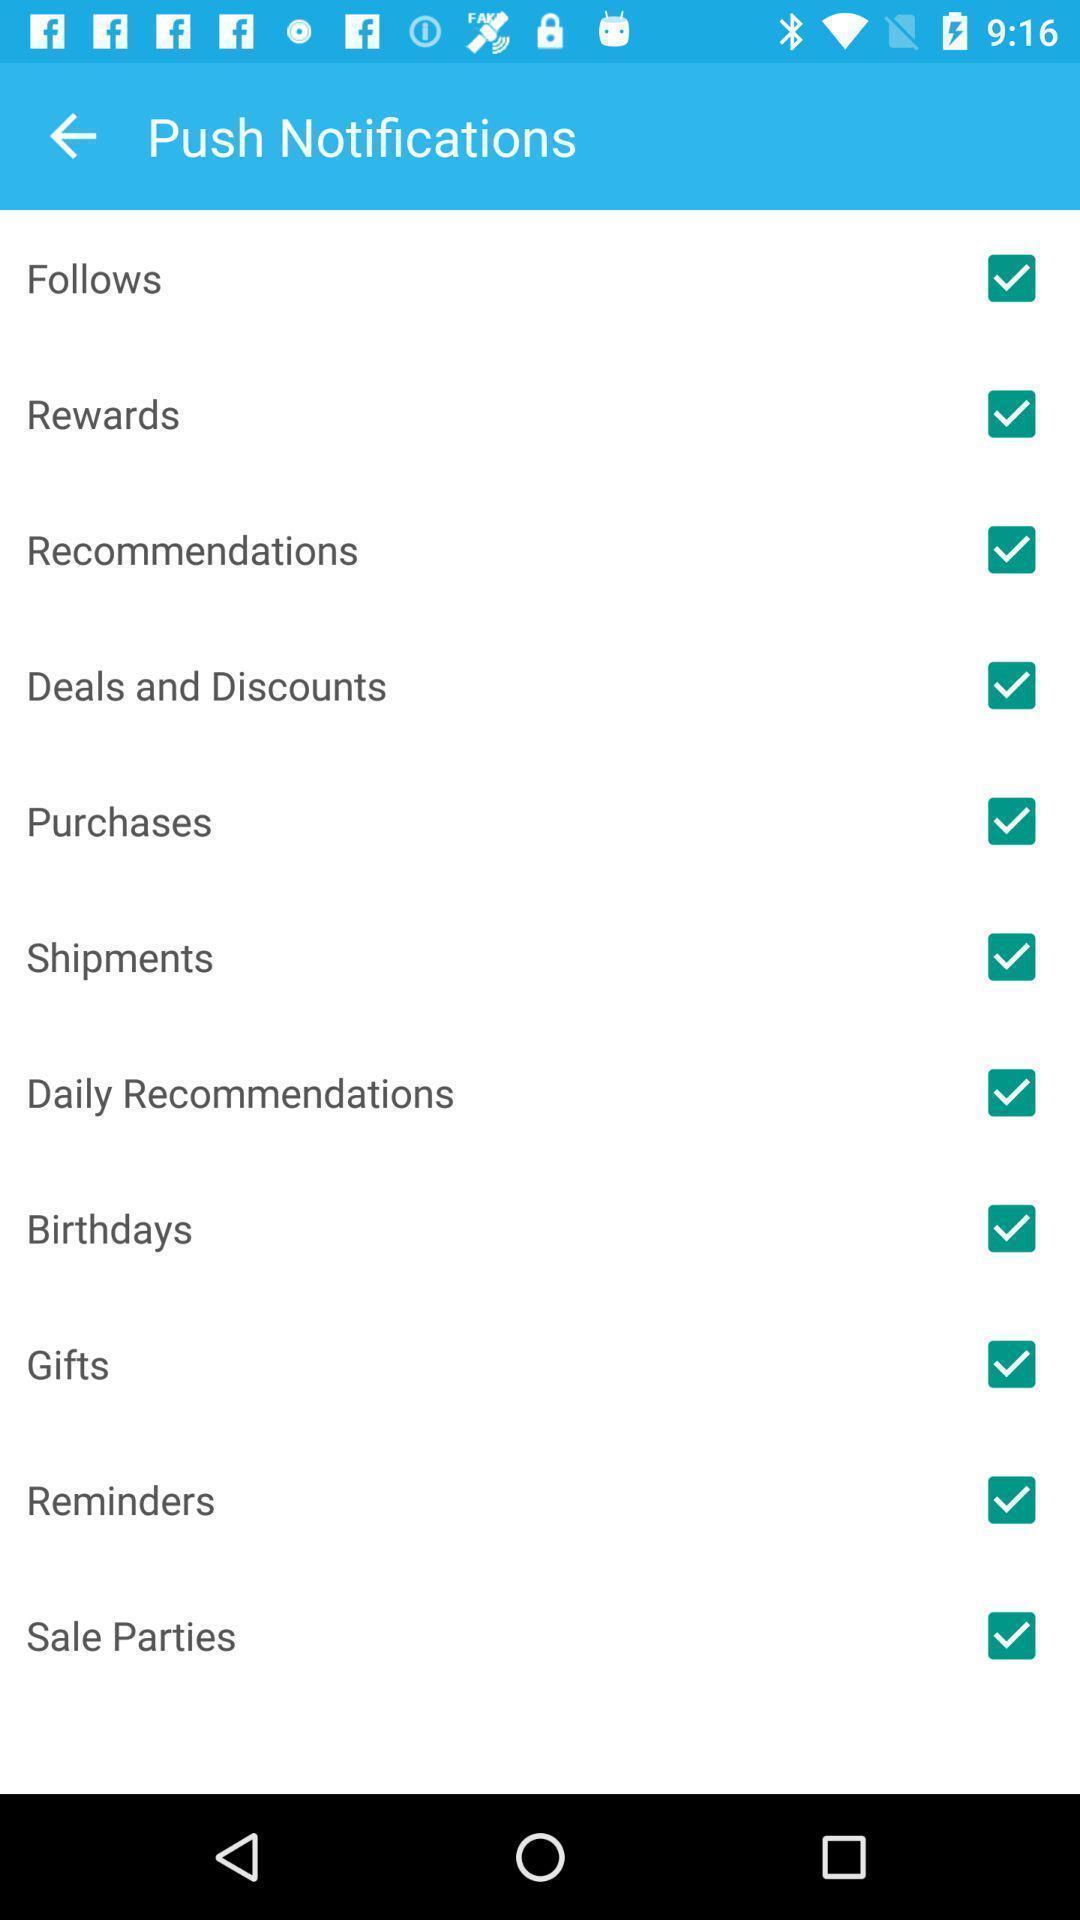What is the overall content of this screenshot? Page showing list of categories on app. 